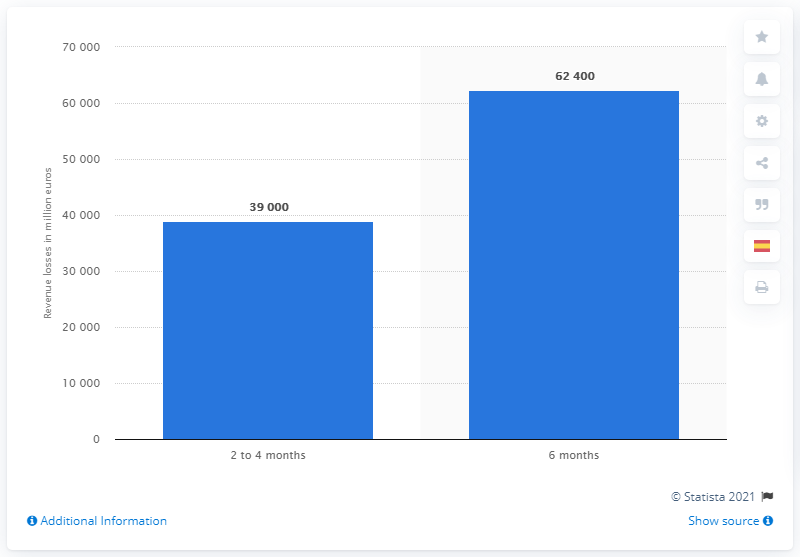Mention a couple of crucial points in this snapshot. The tourism sector could potentially lose approximately 62,400 if the crisis continued until September 2020. 